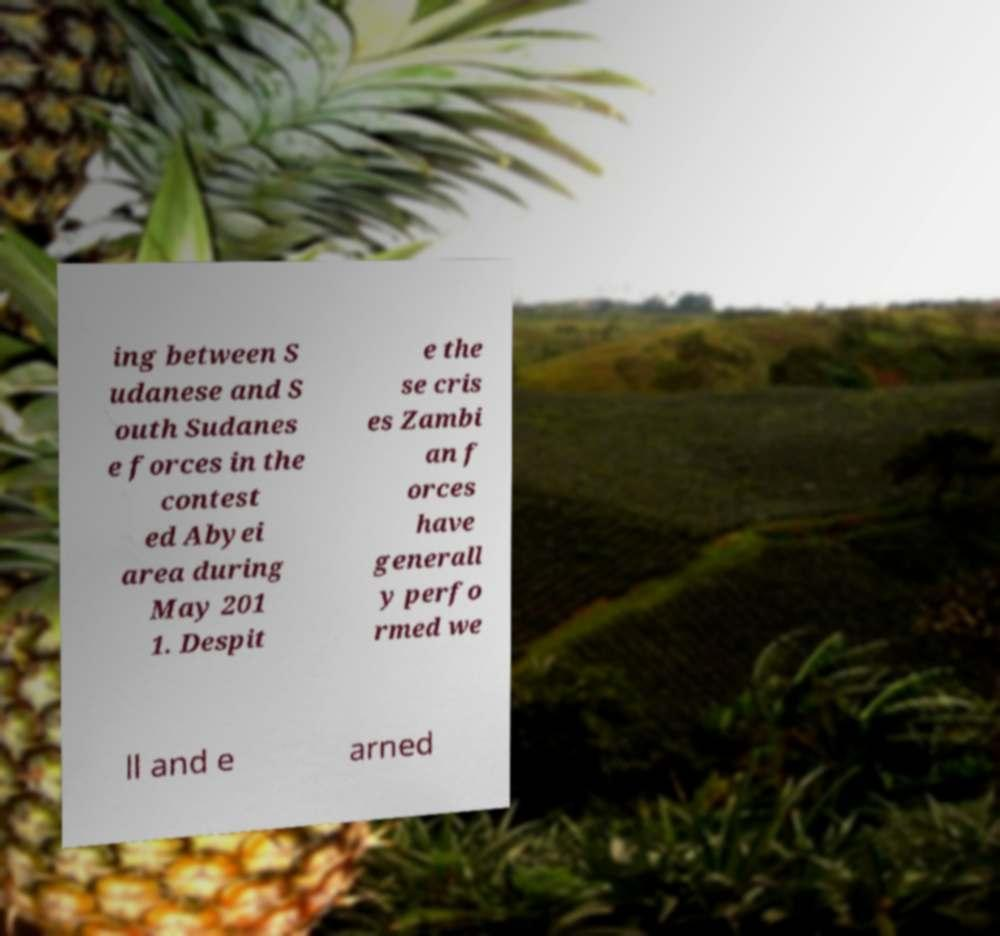Could you extract and type out the text from this image? ing between S udanese and S outh Sudanes e forces in the contest ed Abyei area during May 201 1. Despit e the se cris es Zambi an f orces have generall y perfo rmed we ll and e arned 